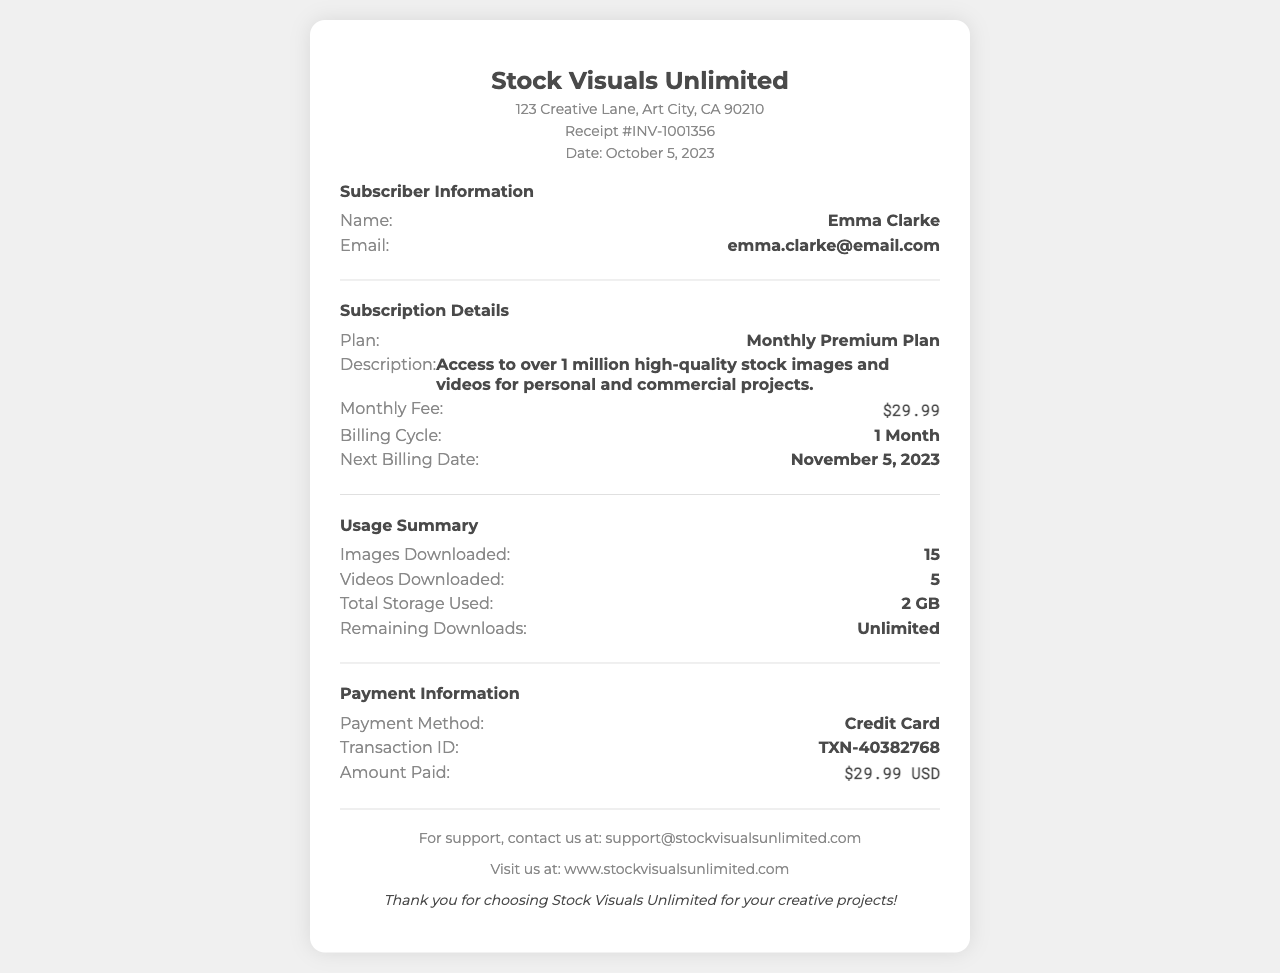What is the name of the subscriber? The subscriber's name is clearly stated in the document under Subscriber Information.
Answer: Emma Clarke What is the monthly fee for the subscription? The monthly fee is listed in the Subscription Details section of the document.
Answer: $29.99 What is the next billing date? The next billing date is mentioned in the Subscription Details section, providing important billing information.
Answer: November 5, 2023 How many images have been downloaded? The number of images downloaded is highlighted in the Usage Summary section.
Answer: 15 What payment method was used? The payment method is stated in the Payment Information section, indicating how the transaction was conducted.
Answer: Credit Card How many videos have been downloaded? The document includes the count of videos downloaded in the Usage Summary section for clarity.
Answer: 5 What is the transaction ID? The transaction ID is provided in the Payment Information section, essential for reference.
Answer: TXN-40382768 What is the total storage used? The amount of total storage used is specified in the Usage Summary section, detailing the subscriber's data usage.
Answer: 2 GB What type of plan is mentioned? The plan type is outlined in the Subscription Details, which gives insight into the subscription level.
Answer: Monthly Premium Plan 